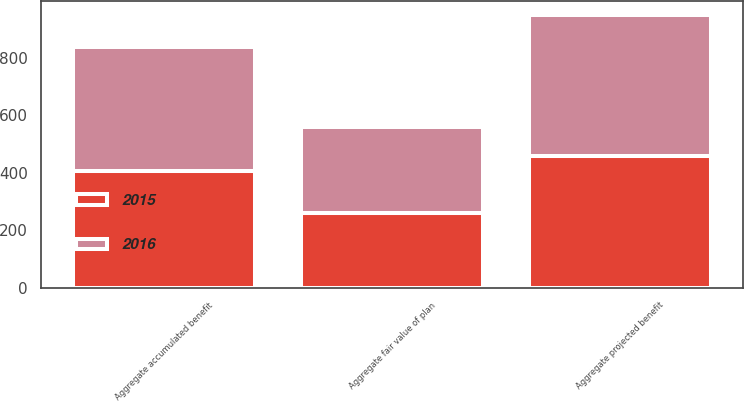<chart> <loc_0><loc_0><loc_500><loc_500><stacked_bar_chart><ecel><fcel>Aggregate projected benefit<fcel>Aggregate accumulated benefit<fcel>Aggregate fair value of plan<nl><fcel>2016<fcel>489.5<fcel>433.1<fcel>297.1<nl><fcel>2015<fcel>459.2<fcel>405.3<fcel>260.9<nl></chart> 